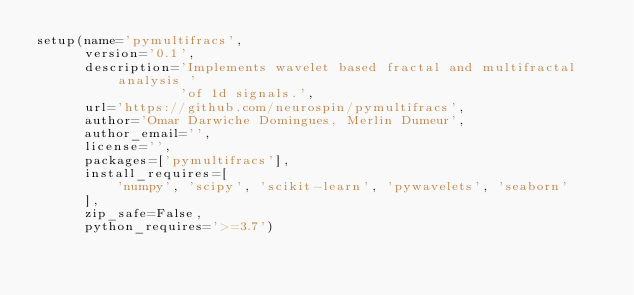<code> <loc_0><loc_0><loc_500><loc_500><_Python_>setup(name='pymultifracs',
      version='0.1',
      description='Implements wavelet based fractal and multifractal analysis '
                  'of 1d signals.',
      url='https://github.com/neurospin/pymultifracs',
      author='Omar Darwiche Domingues, Merlin Dumeur',
      author_email='',
      license='',
      packages=['pymultifracs'],
      install_requires=[
          'numpy', 'scipy', 'scikit-learn', 'pywavelets', 'seaborn'
      ],
      zip_safe=False,
      python_requires='>=3.7')
</code> 